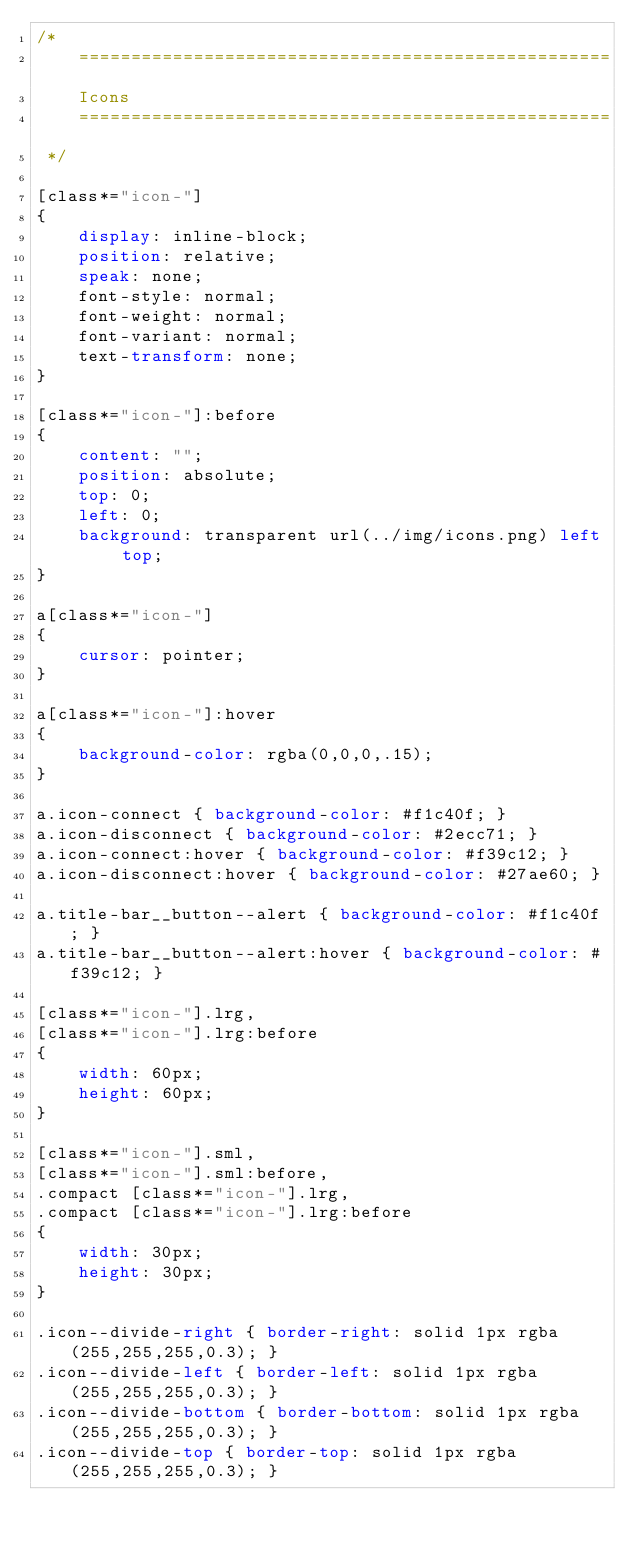<code> <loc_0><loc_0><loc_500><loc_500><_CSS_>/* 
    ===================================================
    Icons
    ===================================================
 */

[class*="icon-"] 
{
    display: inline-block;
    position: relative;
    speak: none;
    font-style: normal;
    font-weight: normal;
    font-variant: normal;
    text-transform: none;
}

[class*="icon-"]:before 
{
    content: "";
    position: absolute;
    top: 0;
    left: 0;
    background: transparent url(../img/icons.png) left top;
}

a[class*="icon-"]
{
    cursor: pointer;
}

a[class*="icon-"]:hover
{
    background-color: rgba(0,0,0,.15);
}

a.icon-connect { background-color: #f1c40f; }
a.icon-disconnect { background-color: #2ecc71; }
a.icon-connect:hover { background-color: #f39c12; }
a.icon-disconnect:hover { background-color: #27ae60; }

a.title-bar__button--alert { background-color: #f1c40f; }
a.title-bar__button--alert:hover { background-color: #f39c12; }

[class*="icon-"].lrg,
[class*="icon-"].lrg:before
{
    width: 60px;
    height: 60px;
}

[class*="icon-"].sml,
[class*="icon-"].sml:before,
.compact [class*="icon-"].lrg,
.compact [class*="icon-"].lrg:before
{
    width: 30px;
    height: 30px;
}

.icon--divide-right { border-right: solid 1px rgba(255,255,255,0.3); }
.icon--divide-left { border-left: solid 1px rgba(255,255,255,0.3); }
.icon--divide-bottom { border-bottom: solid 1px rgba(255,255,255,0.3); }
.icon--divide-top { border-top: solid 1px rgba(255,255,255,0.3); }


</code> 